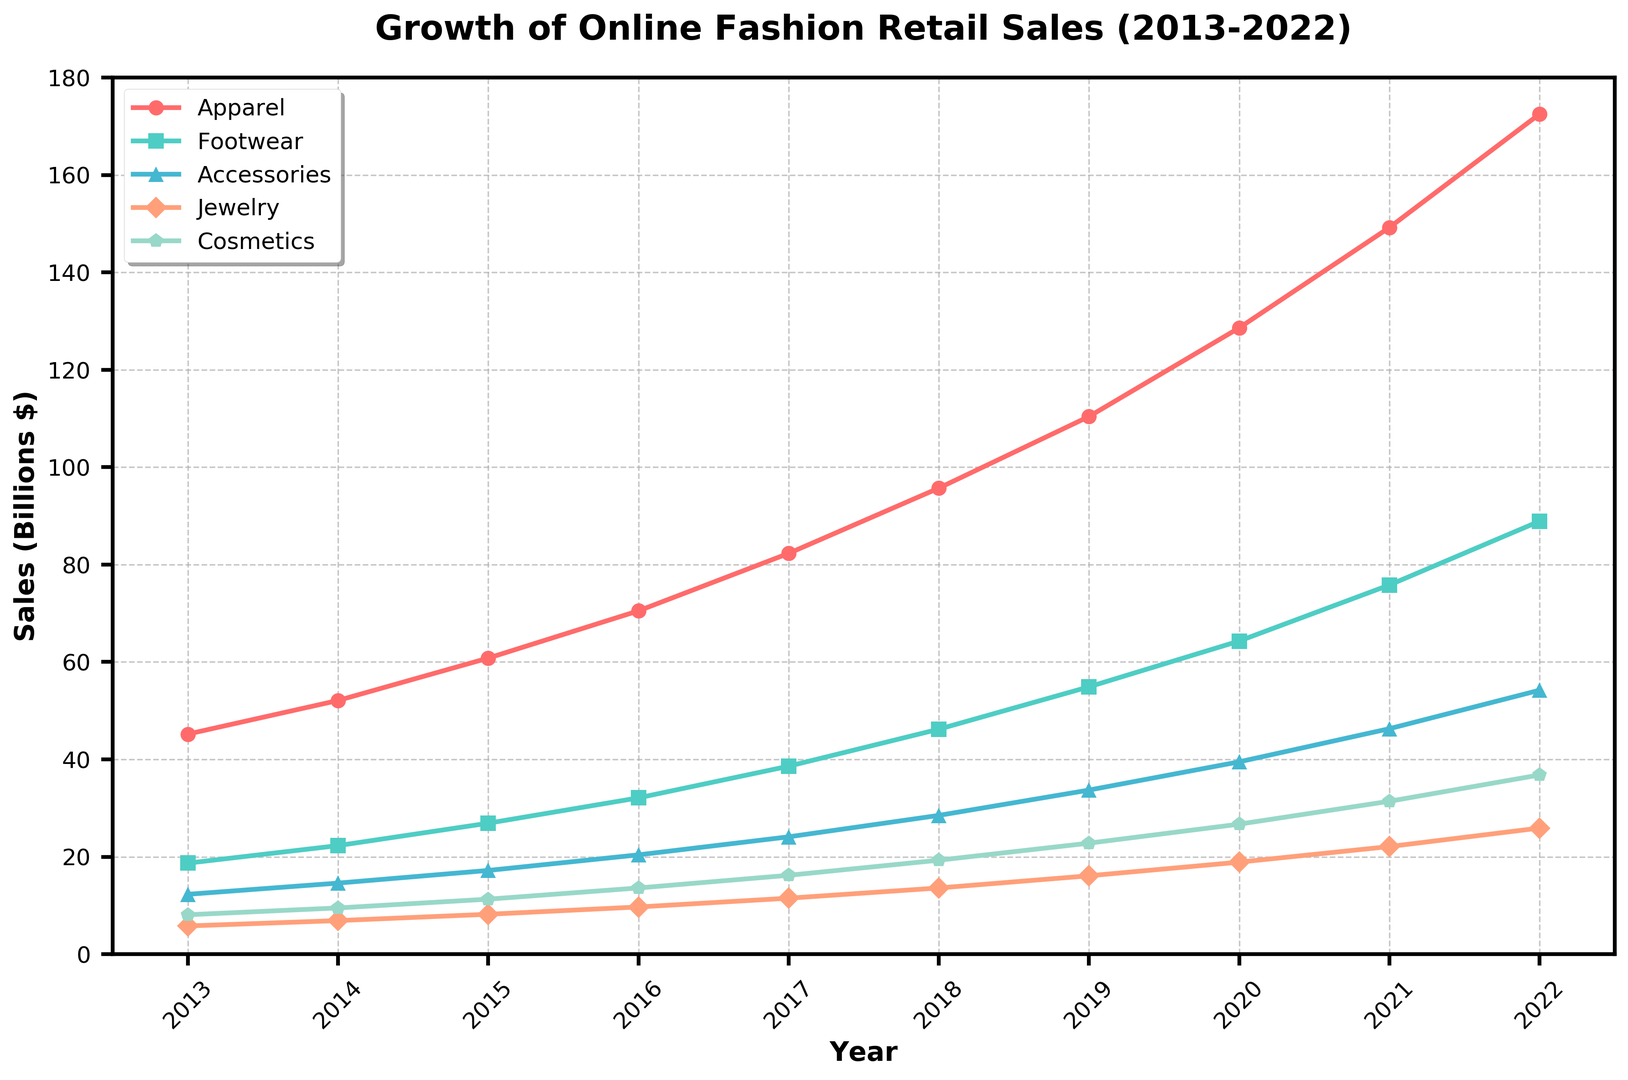What was the growth in sales for Apparel from 2013 to 2022? To find the growth in sales for Apparel from 2013 to 2022, subtract the sales figure in 2013 from the sales figure in 2022. That is 172.5 - 45.2.
Answer: 127.3 In what year did Footwear sales surpass 50 billion dollars? By examining the data series for Footwear, the sales surpass 50 billion in 2019 with a value of 54.9 billion dollars.
Answer: 2019 Which product category had the lowest sales in 2022? Comparing the sales figures of all product categories in 2022, Jewelry has the lowest sales at 25.9 billion dollars.
Answer: Jewelry How did Cosmetics sales in 2020 compare to those in 2013? To compare Cosmetics sales in 2020 to those in 2013, we subtract the 2013 value from the 2020 value: 26.7 - 8.1. The difference is 18.6 billion dollars, showing a significant increase by 2020.
Answer: Increased by 18.6 billion dollars Which year had a higher increase in sales for Accessories: 2015 to 2016 or 2016 to 2017? The increase from 2015 to 2016 is 20.4 - 17.2 = 3.2 billion dollars. The increase from 2016 to 2017 is 24.1 - 20.4 = 3.7 billion dollars. Hence, the increase was higher from 2016 to 2017.
Answer: 2016 to 2017 Was there any year when Jewelry sales decreased compared to the previous year? By examining the Jewelry sales data year by year, there is no year where Jewelry sales decreased; the sales always increased compared to the previous year.
Answer: No By how much did Apparel sales exceed Accessories sales in 2022? To determine by how much Apparel sales exceeded Accessories sales in 2022, subtract Accessories sales from Apparel sales: 172.5 - 54.2.
Answer: 118.3 What is the trend in the sales of all product categories from 2013 to 2022? All the product categories show an upward trend from 2013 to 2022, indicating steady and significant growth in online fashion retail sales.
Answer: Upward trend Which product category shows the most rapid growth over the decade? By comparing the sales growth from 2013 to 2022 for all categories, Apparel shows the largest increase from 45.2 to 172.5, indicating the most rapid growth.
Answer: Apparel 